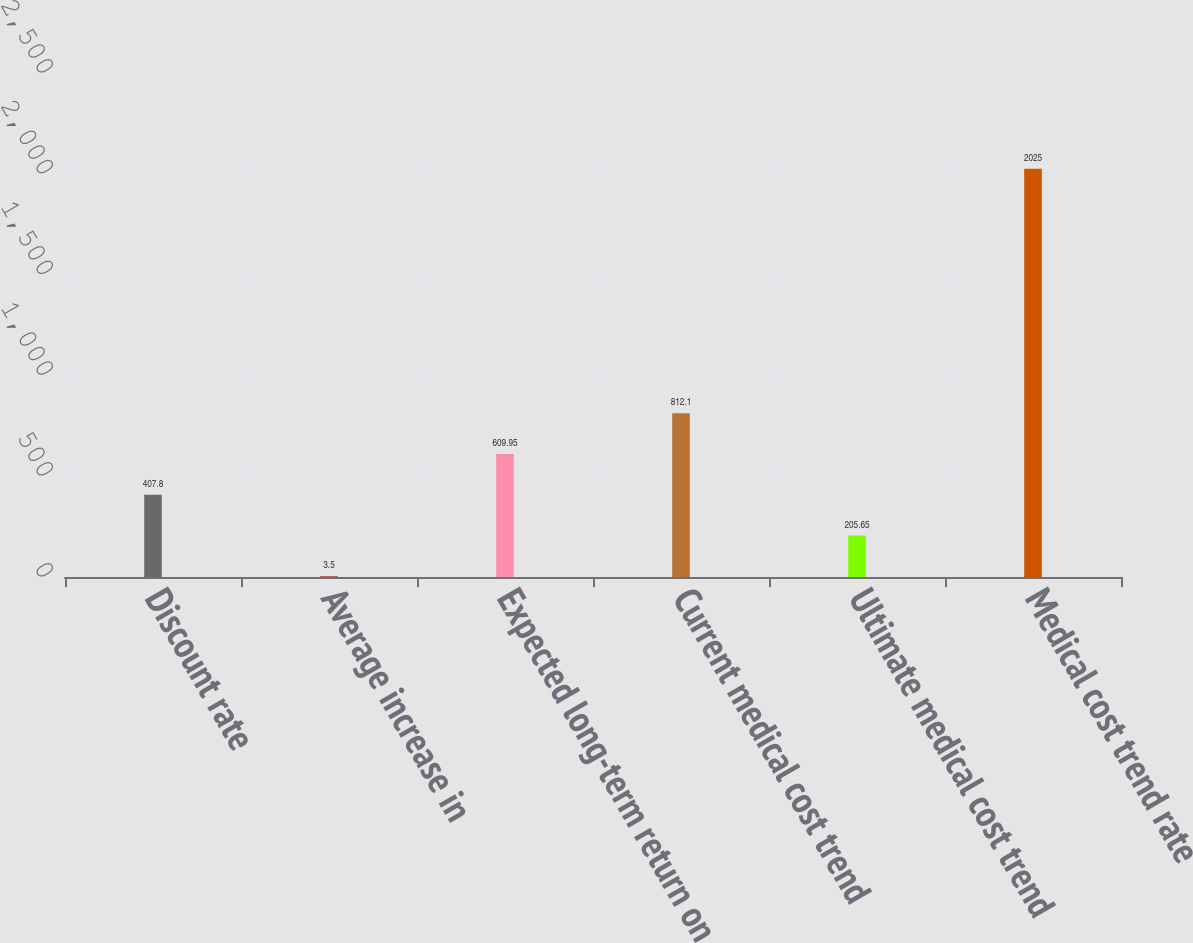Convert chart to OTSL. <chart><loc_0><loc_0><loc_500><loc_500><bar_chart><fcel>Discount rate<fcel>Average increase in<fcel>Expected long-term return on<fcel>Current medical cost trend<fcel>Ultimate medical cost trend<fcel>Medical cost trend rate<nl><fcel>407.8<fcel>3.5<fcel>609.95<fcel>812.1<fcel>205.65<fcel>2025<nl></chart> 